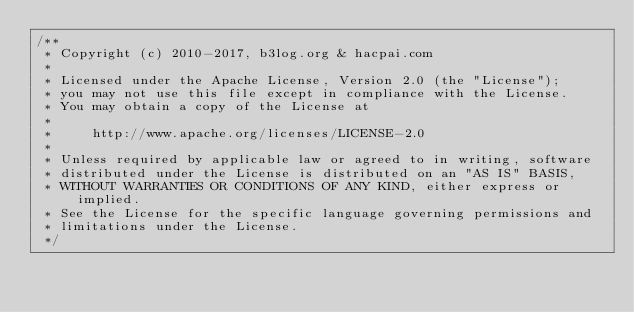Convert code to text. <code><loc_0><loc_0><loc_500><loc_500><_CSS_>/**
 * Copyright (c) 2010-2017, b3log.org & hacpai.com
 *
 * Licensed under the Apache License, Version 2.0 (the "License");
 * you may not use this file except in compliance with the License.
 * You may obtain a copy of the License at
 *
 *     http://www.apache.org/licenses/LICENSE-2.0
 *
 * Unless required by applicable law or agreed to in writing, software
 * distributed under the License is distributed on an "AS IS" BASIS,
 * WITHOUT WARRANTIES OR CONDITIONS OF ANY KIND, either express or implied.
 * See the License for the specific language governing permissions and
 * limitations under the License.
 */</code> 